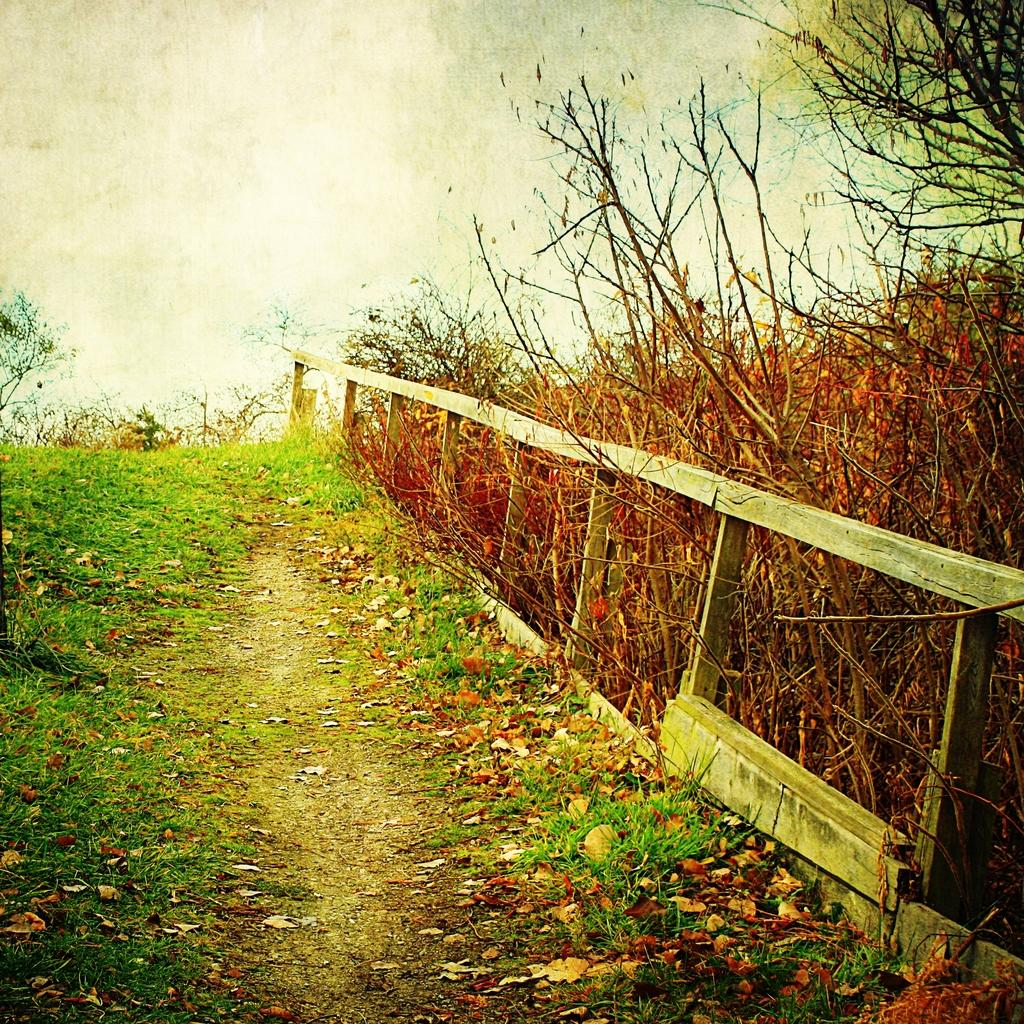What type of vegetation is present on the ground in the image? There is grass on the ground in the image. What other natural elements can be seen in the image? There are trees visible in the image. What type of barrier is present in the image? There is a wooden fence in the image. What type of line can be seen dividing the trees in the image? There is no line dividing the trees in the image; it is a natural scene with trees and grass. What error is present in the image? There is no error present in the image; it is a clear and accurate representation of the scene. 